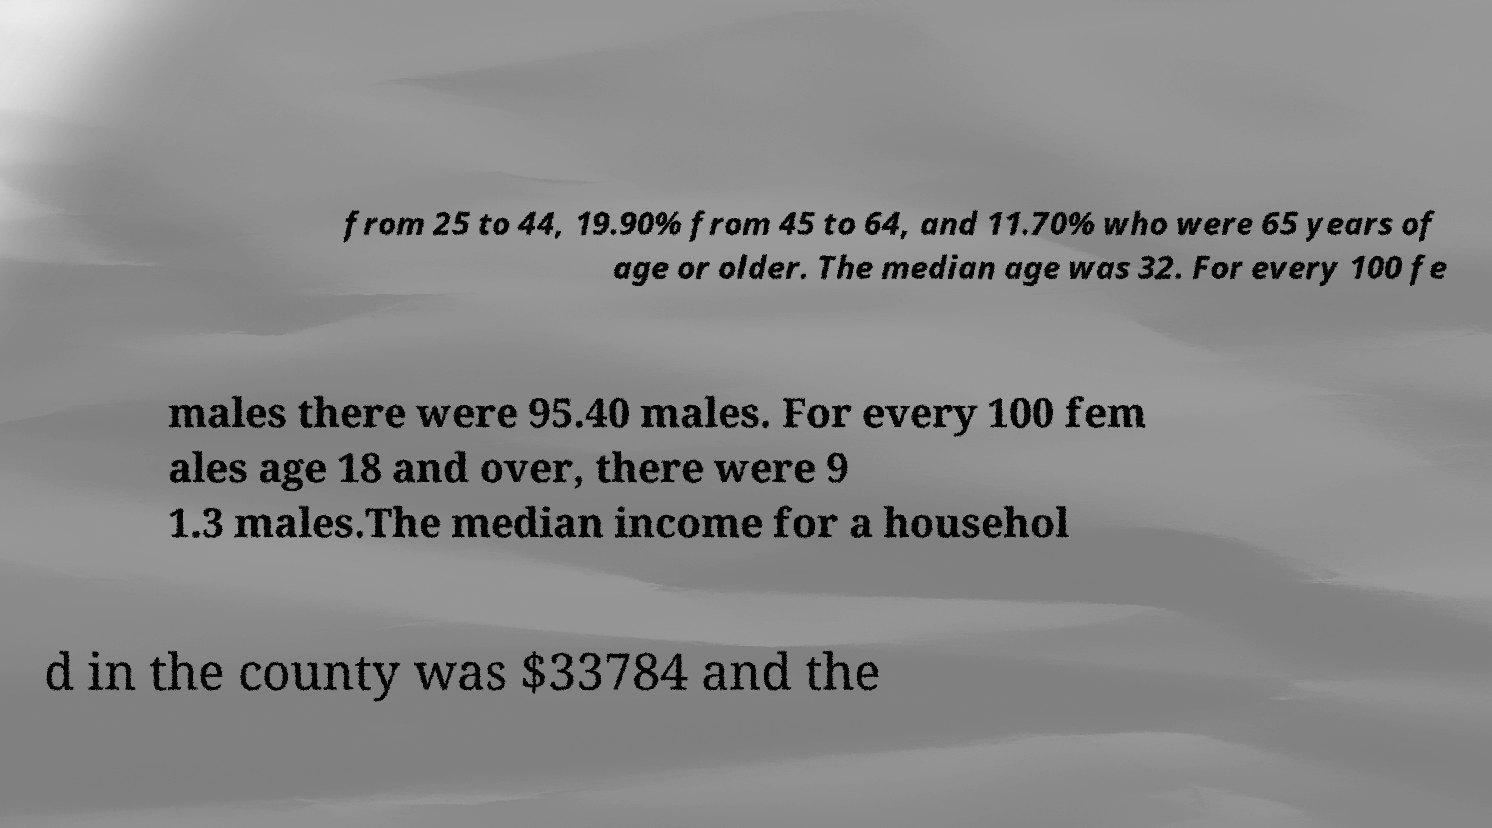Please read and relay the text visible in this image. What does it say? from 25 to 44, 19.90% from 45 to 64, and 11.70% who were 65 years of age or older. The median age was 32. For every 100 fe males there were 95.40 males. For every 100 fem ales age 18 and over, there were 9 1.3 males.The median income for a househol d in the county was $33784 and the 